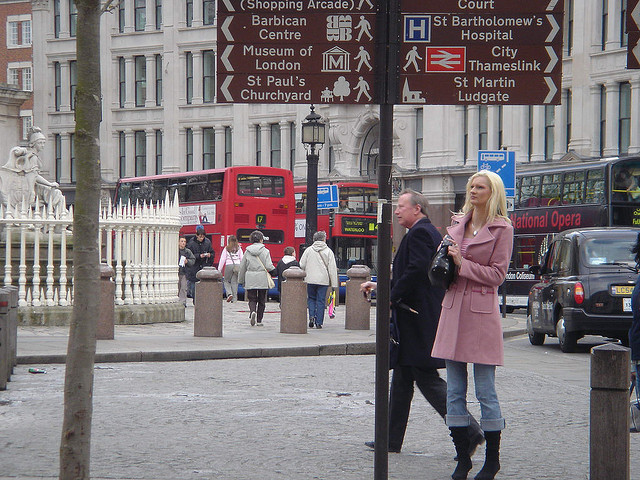Please extract the text content from this image. Barbican Centre Museum of London H Opera national M Ludgate Martin St Thameslink City Hospital Bartholomew's St Court Churchyard Paul's St Arcade Shopping 